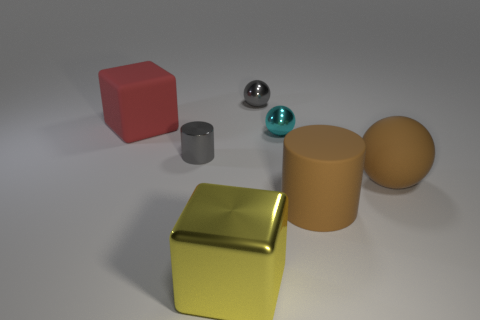Subtract all small shiny spheres. How many spheres are left? 1 Subtract 2 spheres. How many spheres are left? 1 Subtract all brown spheres. How many spheres are left? 2 Add 2 brown objects. How many objects exist? 9 Subtract all gray balls. Subtract all red cylinders. How many balls are left? 2 Subtract all large red cubes. Subtract all metallic balls. How many objects are left? 4 Add 6 large red rubber blocks. How many large red rubber blocks are left? 7 Add 7 brown matte objects. How many brown matte objects exist? 9 Subtract 1 gray balls. How many objects are left? 6 Subtract all cubes. How many objects are left? 5 